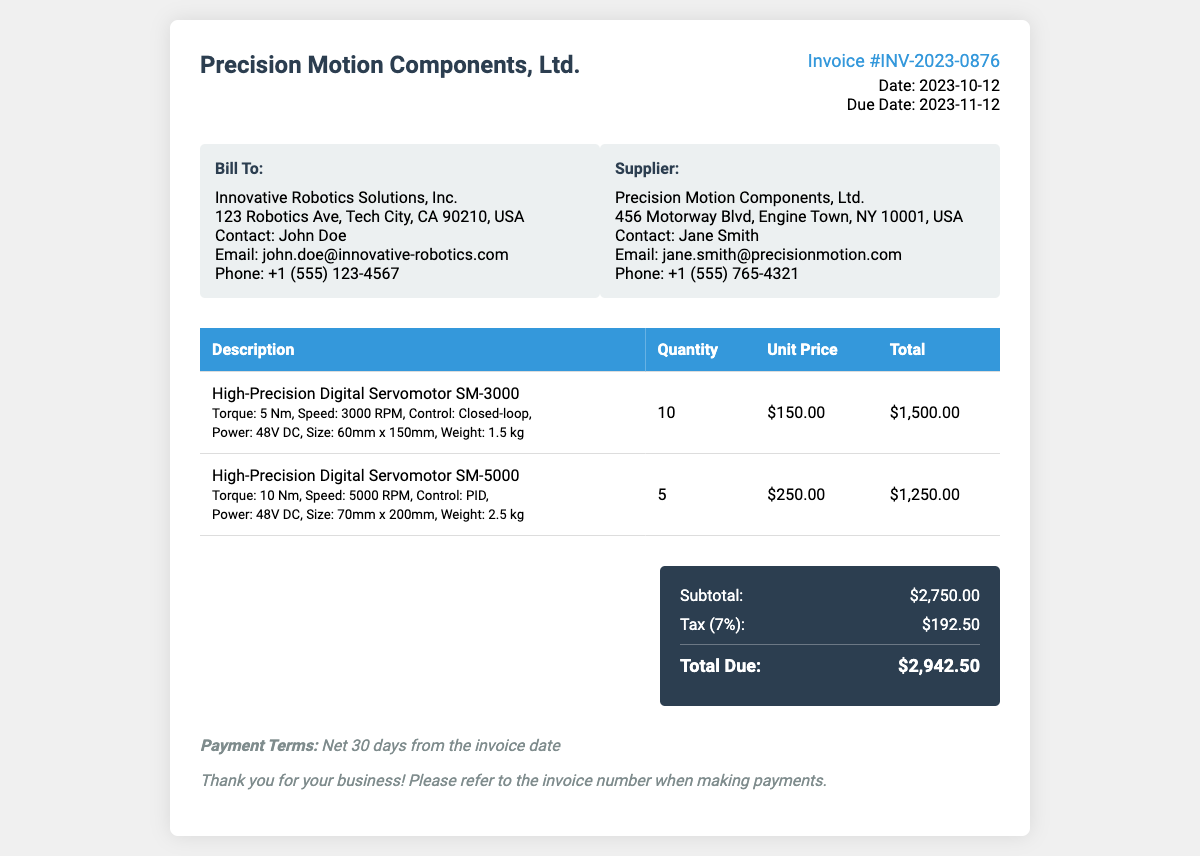What is the invoice number? The invoice number is prominently displayed in the invoice details section.
Answer: INV-2023-0876 What is the due date of the invoice? The due date is specified in the invoice details section.
Answer: 2023-11-12 Who is the contact person for the supplier? The supplier's contact person is listed in the supplier address box.
Answer: Jane Smith How many High-Precision Digital Servomotor SM-3000 units were purchased? The quantity purchased is indicated in the table under the quantity column for that item.
Answer: 10 What is the subtotal amount before tax? The subtotal is calculated from the item totals before tax is applied and is shown in the summary section.
Answer: $2,750.00 What is the tax rate applied in this invoice? The tax percentage is listed next to the tax calculation in the summary section.
Answer: 7% What is the total due amount? The total due is the final amount after tax, shown prominently at the bottom of the summary section.
Answer: $2,942.50 What are the payment terms specified in the document? The payment terms are found in the notes section at the end of the invoice.
Answer: Net 30 days from the invoice date What size is the High-Precision Digital Servomotor SM-5000? The size of the SM-5000 is provided in the item description in the service table.
Answer: 70mm x 200mm 